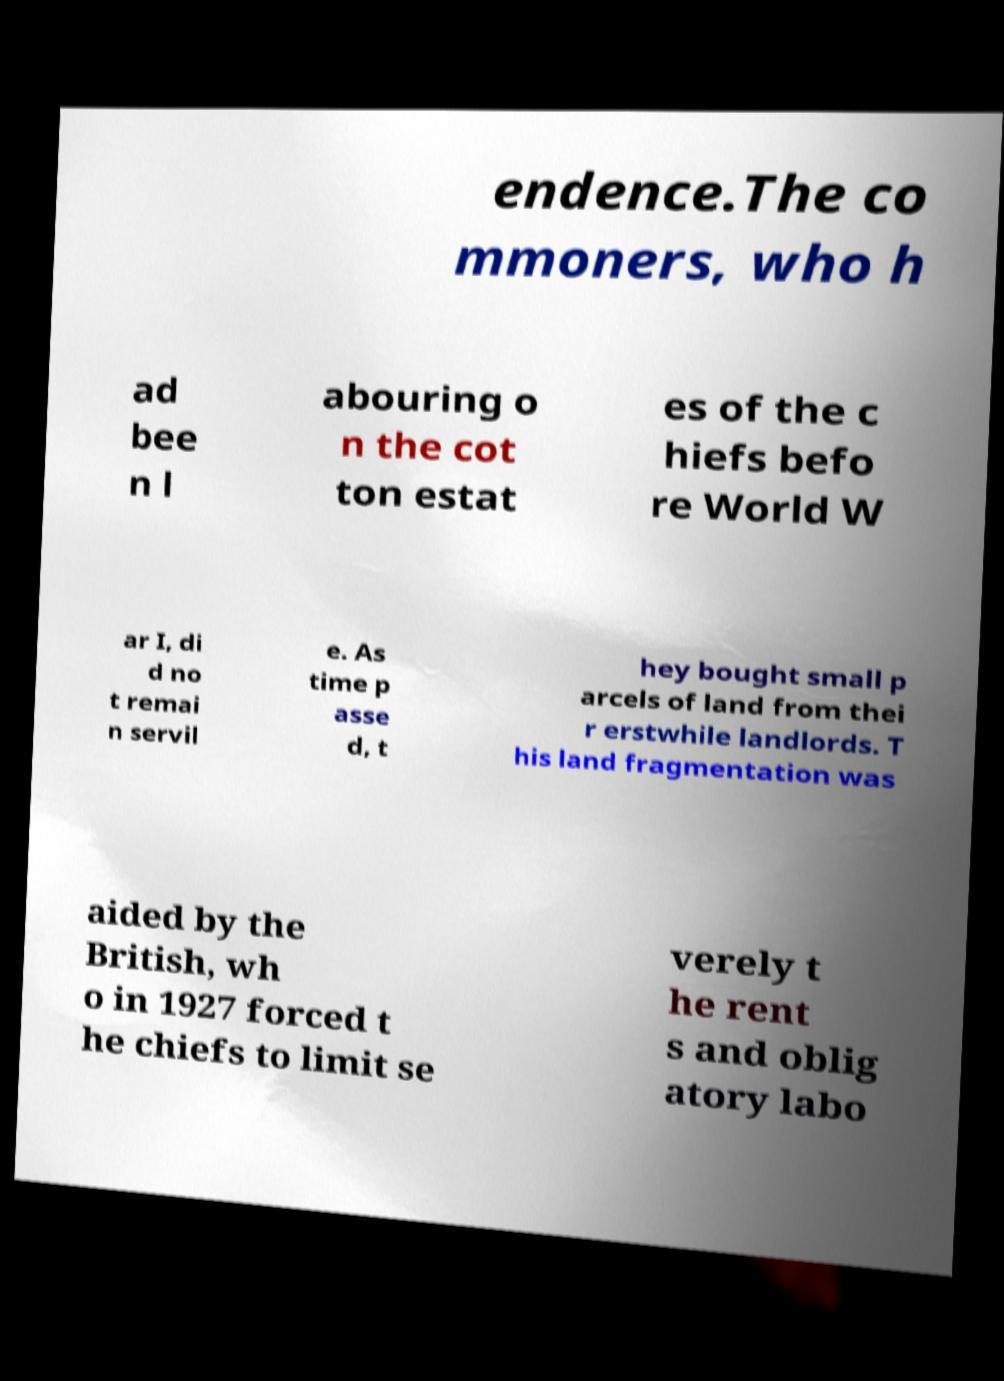Could you extract and type out the text from this image? endence.The co mmoners, who h ad bee n l abouring o n the cot ton estat es of the c hiefs befo re World W ar I, di d no t remai n servil e. As time p asse d, t hey bought small p arcels of land from thei r erstwhile landlords. T his land fragmentation was aided by the British, wh o in 1927 forced t he chiefs to limit se verely t he rent s and oblig atory labo 